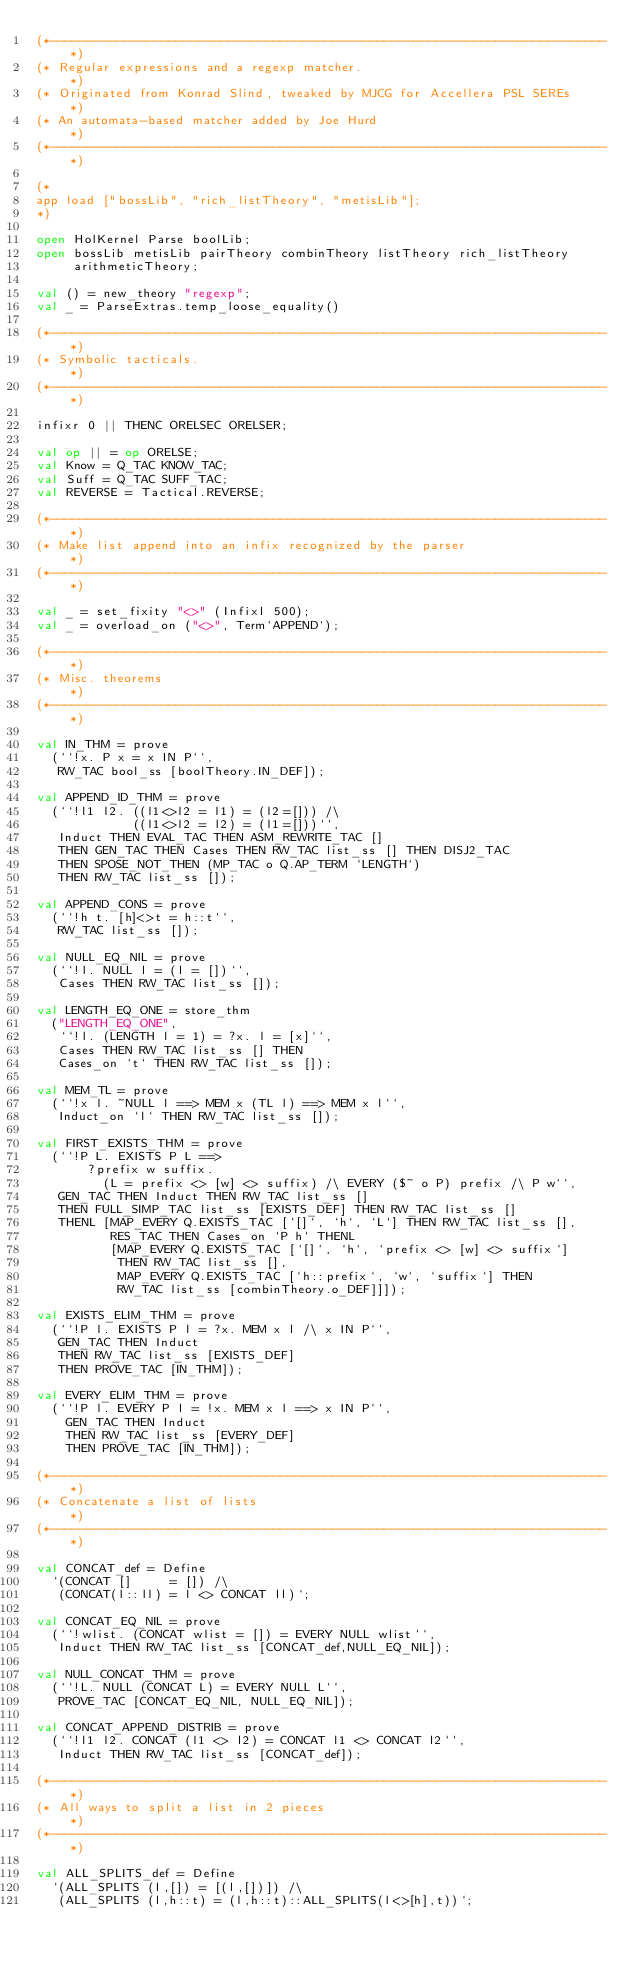<code> <loc_0><loc_0><loc_500><loc_500><_SML_>(*---------------------------------------------------------------------------*)
(* Regular expressions and a regexp matcher.                                 *)
(* Originated from Konrad Slind, tweaked by MJCG for Accellera PSL SEREs     *)
(* An automata-based matcher added by Joe Hurd                               *)
(*---------------------------------------------------------------------------*)

(*
app load ["bossLib", "rich_listTheory", "metisLib"];
*)

open HolKernel Parse boolLib;
open bossLib metisLib pairTheory combinTheory listTheory rich_listTheory
     arithmeticTheory;

val () = new_theory "regexp";
val _ = ParseExtras.temp_loose_equality()

(*---------------------------------------------------------------------------*)
(* Symbolic tacticals.                                                       *)
(*---------------------------------------------------------------------------*)

infixr 0 || THENC ORELSEC ORELSER;

val op || = op ORELSE;
val Know = Q_TAC KNOW_TAC;
val Suff = Q_TAC SUFF_TAC;
val REVERSE = Tactical.REVERSE;

(*---------------------------------------------------------------------------*)
(* Make list append into an infix recognized by the parser                   *)
(*---------------------------------------------------------------------------*)

val _ = set_fixity "<>" (Infixl 500);
val _ = overload_on ("<>", Term`APPEND`);

(*---------------------------------------------------------------------------*)
(* Misc. theorems                                                            *)
(*---------------------------------------------------------------------------*)

val IN_THM = prove
  (``!x. P x = x IN P``,
   RW_TAC bool_ss [boolTheory.IN_DEF]);

val APPEND_ID_THM = prove
  (``!l1 l2. ((l1<>l2 = l1) = (l2=[])) /\
             ((l1<>l2 = l2) = (l1=[]))``,
   Induct THEN EVAL_TAC THEN ASM_REWRITE_TAC []
   THEN GEN_TAC THEN Cases THEN RW_TAC list_ss [] THEN DISJ2_TAC
   THEN SPOSE_NOT_THEN (MP_TAC o Q.AP_TERM `LENGTH`)
   THEN RW_TAC list_ss []);

val APPEND_CONS = prove
  (``!h t. [h]<>t = h::t``,
   RW_TAC list_ss []);

val NULL_EQ_NIL = prove
  (``!l. NULL l = (l = [])``,
   Cases THEN RW_TAC list_ss []);

val LENGTH_EQ_ONE = store_thm
  ("LENGTH_EQ_ONE",
   ``!l. (LENGTH l = 1) = ?x. l = [x]``,
   Cases THEN RW_TAC list_ss [] THEN
   Cases_on `t` THEN RW_TAC list_ss []);

val MEM_TL = prove
  (``!x l. ~NULL l ==> MEM x (TL l) ==> MEM x l``,
   Induct_on `l` THEN RW_TAC list_ss []);

val FIRST_EXISTS_THM = prove
  (``!P L. EXISTS P L ==>
       ?prefix w suffix.
         (L = prefix <> [w] <> suffix) /\ EVERY ($~ o P) prefix /\ P w``,
   GEN_TAC THEN Induct THEN RW_TAC list_ss []
   THEN FULL_SIMP_TAC list_ss [EXISTS_DEF] THEN RW_TAC list_ss []
   THENL [MAP_EVERY Q.EXISTS_TAC [`[]`, `h`, `L`] THEN RW_TAC list_ss [],
          RES_TAC THEN Cases_on `P h` THENL
          [MAP_EVERY Q.EXISTS_TAC [`[]`, `h`, `prefix <> [w] <> suffix`]
           THEN RW_TAC list_ss [],
           MAP_EVERY Q.EXISTS_TAC [`h::prefix`, `w`, `suffix`] THEN
           RW_TAC list_ss [combinTheory.o_DEF]]]);

val EXISTS_ELIM_THM = prove
  (``!P l. EXISTS P l = ?x. MEM x l /\ x IN P``,
   GEN_TAC THEN Induct
   THEN RW_TAC list_ss [EXISTS_DEF]
   THEN PROVE_TAC [IN_THM]);

val EVERY_ELIM_THM = prove
  (``!P l. EVERY P l = !x. MEM x l ==> x IN P``,
    GEN_TAC THEN Induct
    THEN RW_TAC list_ss [EVERY_DEF]
    THEN PROVE_TAC [IN_THM]);

(*---------------------------------------------------------------------------*)
(* Concatenate a list of lists                                               *)
(*---------------------------------------------------------------------------*)

val CONCAT_def = Define
  `(CONCAT []     = []) /\
   (CONCAT(l::ll) = l <> CONCAT ll)`;

val CONCAT_EQ_NIL = prove
  (``!wlist. (CONCAT wlist = []) = EVERY NULL wlist``,
   Induct THEN RW_TAC list_ss [CONCAT_def,NULL_EQ_NIL]);

val NULL_CONCAT_THM = prove
  (``!L. NULL (CONCAT L) = EVERY NULL L``,
   PROVE_TAC [CONCAT_EQ_NIL, NULL_EQ_NIL]);

val CONCAT_APPEND_DISTRIB = prove
  (``!l1 l2. CONCAT (l1 <> l2) = CONCAT l1 <> CONCAT l2``,
   Induct THEN RW_TAC list_ss [CONCAT_def]);

(*---------------------------------------------------------------------------*)
(* All ways to split a list in 2 pieces                                      *)
(*---------------------------------------------------------------------------*)

val ALL_SPLITS_def = Define
  `(ALL_SPLITS (l,[]) = [(l,[])]) /\
   (ALL_SPLITS (l,h::t) = (l,h::t)::ALL_SPLITS(l<>[h],t))`;
</code> 